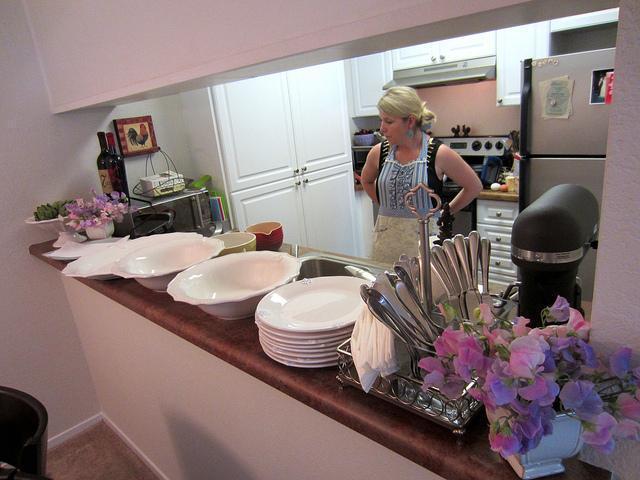How many people are there?
Give a very brief answer. 1. How many cans are on the bar?
Give a very brief answer. 0. How many potted plants are in the photo?
Give a very brief answer. 2. How many ovens can be seen?
Give a very brief answer. 2. How many bowls are there?
Give a very brief answer. 2. How many bikes are shown?
Give a very brief answer. 0. 